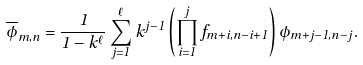<formula> <loc_0><loc_0><loc_500><loc_500>\overline { \phi } _ { m , n } = \frac { 1 } { 1 - k ^ { \ell } } \sum _ { j = 1 } ^ { \ell } k ^ { j - 1 } \left ( \prod _ { i = 1 } ^ { j } f _ { m + i , n - i + 1 } \right ) \phi _ { m + j - 1 , n - j } .</formula> 